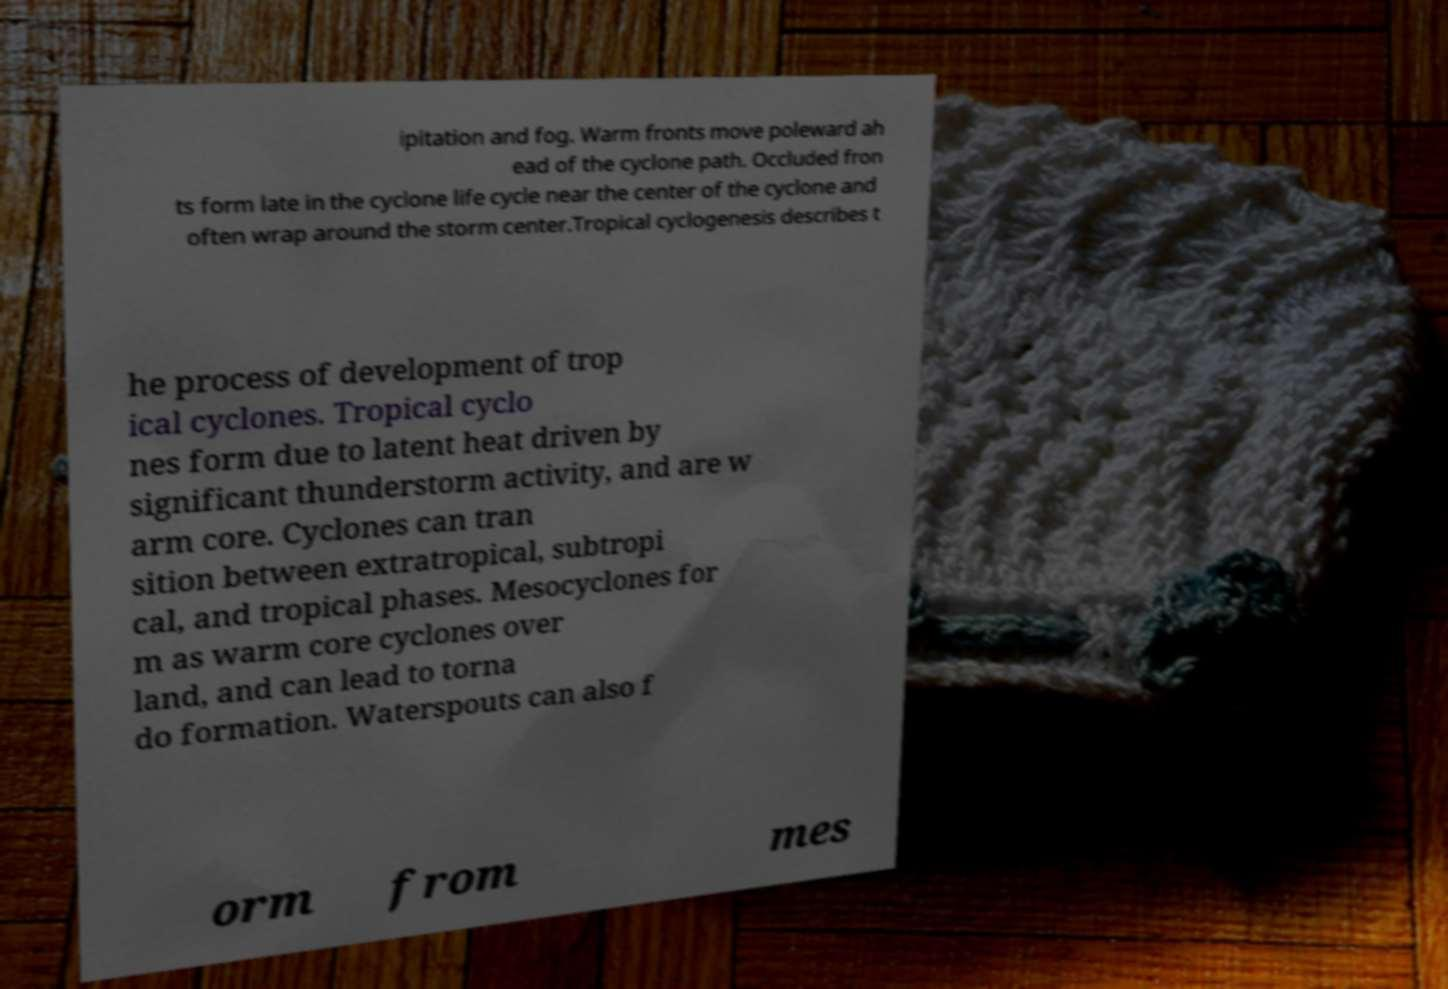Could you assist in decoding the text presented in this image and type it out clearly? ipitation and fog. Warm fronts move poleward ah ead of the cyclone path. Occluded fron ts form late in the cyclone life cycle near the center of the cyclone and often wrap around the storm center.Tropical cyclogenesis describes t he process of development of trop ical cyclones. Tropical cyclo nes form due to latent heat driven by significant thunderstorm activity, and are w arm core. Cyclones can tran sition between extratropical, subtropi cal, and tropical phases. Mesocyclones for m as warm core cyclones over land, and can lead to torna do formation. Waterspouts can also f orm from mes 